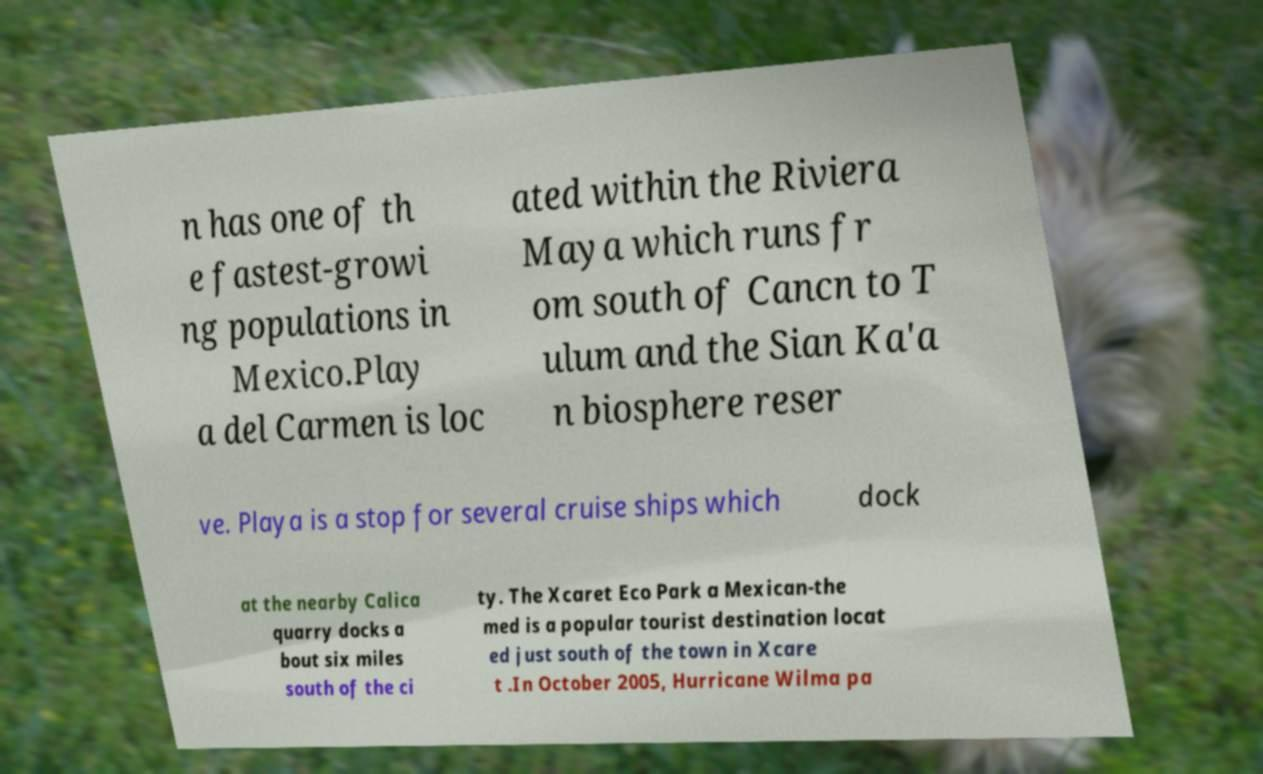Could you assist in decoding the text presented in this image and type it out clearly? n has one of th e fastest-growi ng populations in Mexico.Play a del Carmen is loc ated within the Riviera Maya which runs fr om south of Cancn to T ulum and the Sian Ka'a n biosphere reser ve. Playa is a stop for several cruise ships which dock at the nearby Calica quarry docks a bout six miles south of the ci ty. The Xcaret Eco Park a Mexican-the med is a popular tourist destination locat ed just south of the town in Xcare t .In October 2005, Hurricane Wilma pa 